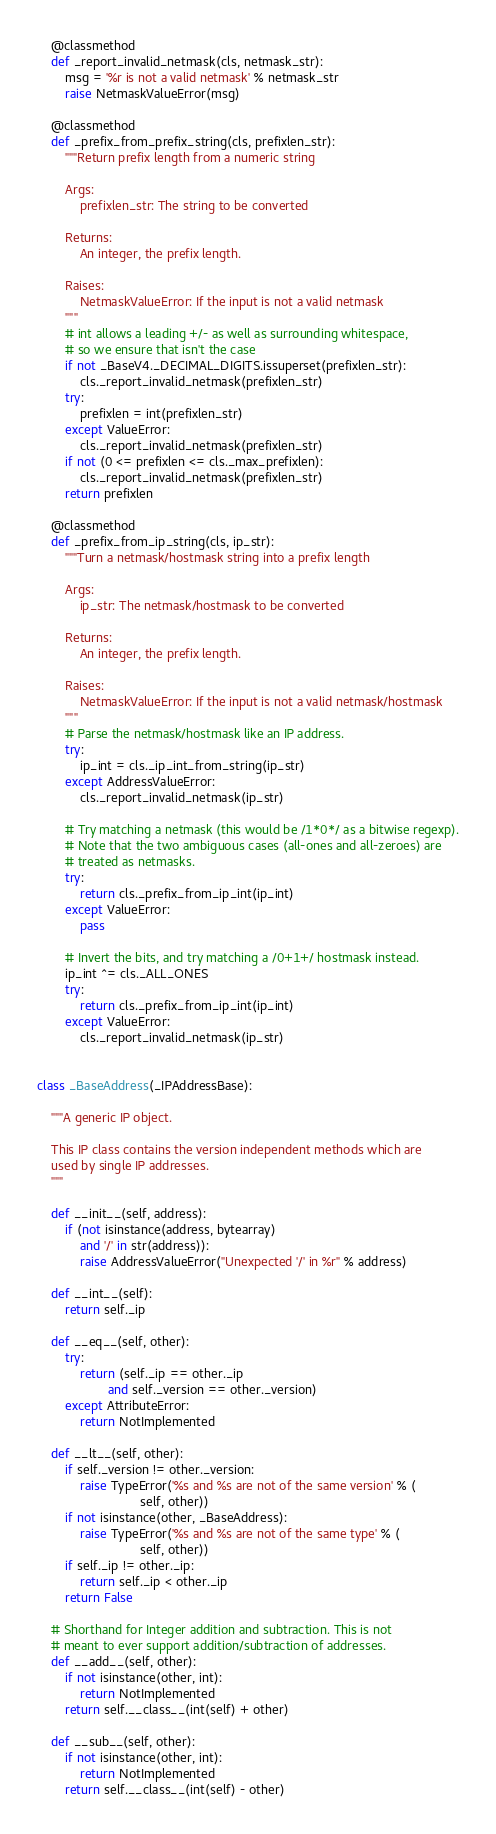Convert code to text. <code><loc_0><loc_0><loc_500><loc_500><_Python_>    @classmethod
    def _report_invalid_netmask(cls, netmask_str):
        msg = '%r is not a valid netmask' % netmask_str
        raise NetmaskValueError(msg)

    @classmethod
    def _prefix_from_prefix_string(cls, prefixlen_str):
        """Return prefix length from a numeric string

        Args:
            prefixlen_str: The string to be converted

        Returns:
            An integer, the prefix length.

        Raises:
            NetmaskValueError: If the input is not a valid netmask
        """
        # int allows a leading +/- as well as surrounding whitespace,
        # so we ensure that isn't the case
        if not _BaseV4._DECIMAL_DIGITS.issuperset(prefixlen_str):
            cls._report_invalid_netmask(prefixlen_str)
        try:
            prefixlen = int(prefixlen_str)
        except ValueError:
            cls._report_invalid_netmask(prefixlen_str)
        if not (0 <= prefixlen <= cls._max_prefixlen):
            cls._report_invalid_netmask(prefixlen_str)
        return prefixlen

    @classmethod
    def _prefix_from_ip_string(cls, ip_str):
        """Turn a netmask/hostmask string into a prefix length

        Args:
            ip_str: The netmask/hostmask to be converted

        Returns:
            An integer, the prefix length.

        Raises:
            NetmaskValueError: If the input is not a valid netmask/hostmask
        """
        # Parse the netmask/hostmask like an IP address.
        try:
            ip_int = cls._ip_int_from_string(ip_str)
        except AddressValueError:
            cls._report_invalid_netmask(ip_str)

        # Try matching a netmask (this would be /1*0*/ as a bitwise regexp).
        # Note that the two ambiguous cases (all-ones and all-zeroes) are
        # treated as netmasks.
        try:
            return cls._prefix_from_ip_int(ip_int)
        except ValueError:
            pass

        # Invert the bits, and try matching a /0+1+/ hostmask instead.
        ip_int ^= cls._ALL_ONES
        try:
            return cls._prefix_from_ip_int(ip_int)
        except ValueError:
            cls._report_invalid_netmask(ip_str)


class _BaseAddress(_IPAddressBase):

    """A generic IP object.

    This IP class contains the version independent methods which are
    used by single IP addresses.
    """

    def __init__(self, address):
        if (not isinstance(address, bytearray)
            and '/' in str(address)):
            raise AddressValueError("Unexpected '/' in %r" % address)

    def __int__(self):
        return self._ip

    def __eq__(self, other):
        try:
            return (self._ip == other._ip
                    and self._version == other._version)
        except AttributeError:
            return NotImplemented

    def __lt__(self, other):
        if self._version != other._version:
            raise TypeError('%s and %s are not of the same version' % (
                             self, other))
        if not isinstance(other, _BaseAddress):
            raise TypeError('%s and %s are not of the same type' % (
                             self, other))
        if self._ip != other._ip:
            return self._ip < other._ip
        return False

    # Shorthand for Integer addition and subtraction. This is not
    # meant to ever support addition/subtraction of addresses.
    def __add__(self, other):
        if not isinstance(other, int):
            return NotImplemented
        return self.__class__(int(self) + other)

    def __sub__(self, other):
        if not isinstance(other, int):
            return NotImplemented
        return self.__class__(int(self) - other)
</code> 